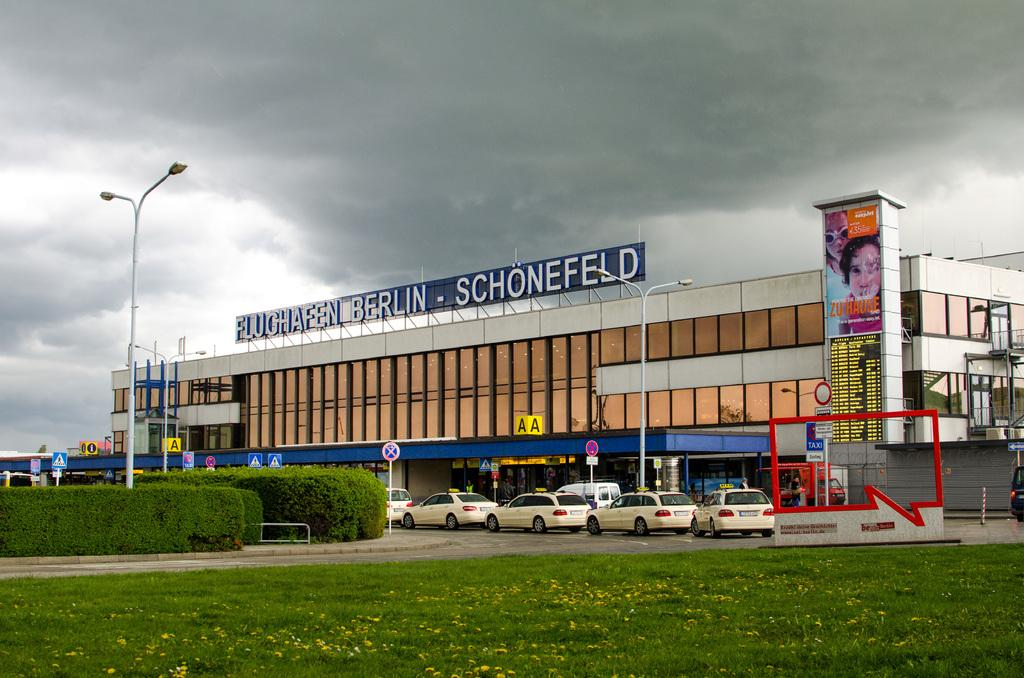What type of vegetation can be seen in the image? There is grass and shrubs in the image. What are the vehicles doing in the image? The vehicles are parked in the image. What safety measure is taken in the image? Caution boards are present in the image. What structures are visible in the image? Light poles and a building are visible in the image. What signage is present in the image? A name board is present in the image. What can be seen in the background of the image? The sky is visible in the background of the image, and it appears to be cloudy. What type of disgust can be seen on the earth in the image? There is no reference to any type of disgust or emotion in the image. The image primarily features grass, shrubs, vehicles, caution boards, light poles, a building, a name board, and a cloudy sky. 